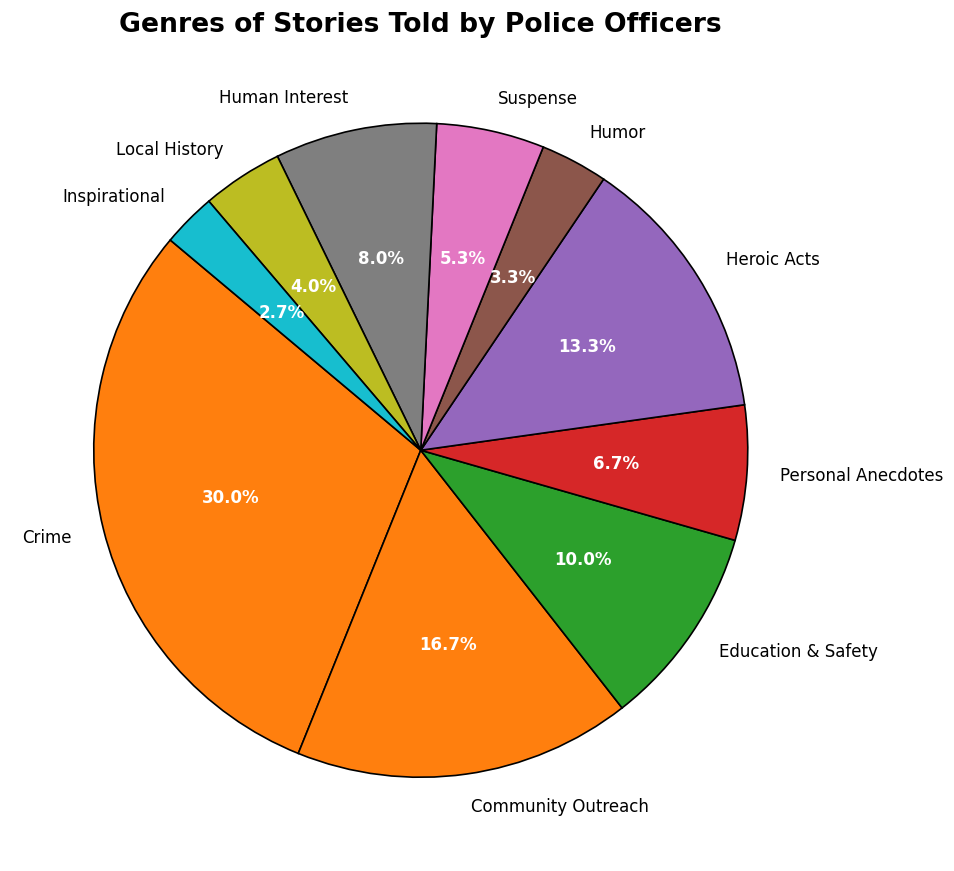What genre has the highest percentage of stories told by police officers? The figure shows the Crime genre has the largest segment, indicated by the highest percentage at 45% of the total stories told.
Answer: Crime Which genre has the smallest percentage of stories shared by police officers? The Inspirational genre has the smallest segment in the pie chart, with only 4% of the total stories.
Answer: Inspirational How much larger is the percentage of Crime stories compared to Humor stories? The percentage of Crime stories is 45%, and Humor stories are 5%. The difference between them is 45% - 5% = 40%.
Answer: 40% What is the combined percentage of stories in the Community Outreach and Heroic Acts genres? The figure shows Community Outreach at 25% and Heroic Acts at 20%. Summing them gives 25% + 20% = 45%.
Answer: 45% Which is more common: Human Interest stories or Local History stories, and by how much? Human Interest stories are 12% and Local History stories are 6%. Human Interest stories are more common by 12% - 6% = 6%.
Answer: Human Interest by 6% Rank the top three genres by storytelling frequency and provide their percentages. The top three genres by their segment sizes are Crime (45%), Community Outreach (25%), and Heroic Acts (20%).
Answer: Crime (45%), Community Outreach (25%), Heroic Acts (20%) What is the average percentage of stories in the Education & Safety, Personal Anecdotes, and Suspense genres? The percentages are 15% for Education & Safety, 10% for Personal Anecdotes, and 8% for Suspense. Their average is (15% + 10% + 8%) / 3 = 11%.
Answer: 11% Which genre is represented by a segment that is approximately one-fifth of the total stories? Heroic Acts represent around 20%, which is approximately one-fifth of the total stories.
Answer: Heroic Acts What is the percentage of genres that are collectively smaller than Crime stories? The genres are: Community Outreach (25%), Education & Safety (15%), Personal Anecdotes (10%), Humor (5%), Suspense (8%), Human Interest (12%), Local History (6%), Inspirational (4%). Summing these gives 25% + 15% + 10% + 5% + 8% + 12% + 6% + 4% = 85%, which is all genres except Crime (45%). 100% - 45% = 55%, so 55% represents the collective percentage.
Answer: 55% If you exclude the largest genre, what is the average percentage of the remaining genres? Excluding Crime (45%), the remaining genres add up to 55% and there are 9 genres in total now. The average is 55% / 9 = 6.1%.
Answer: 6.1% 